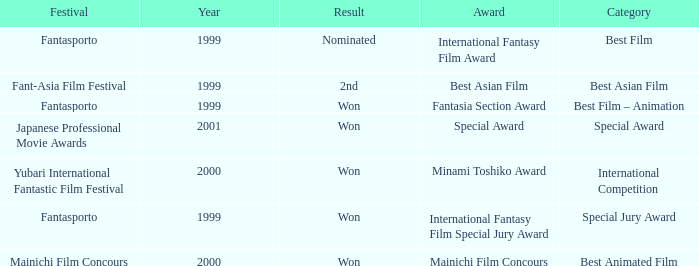What is the average year of the Fantasia Section Award? 1999.0. 